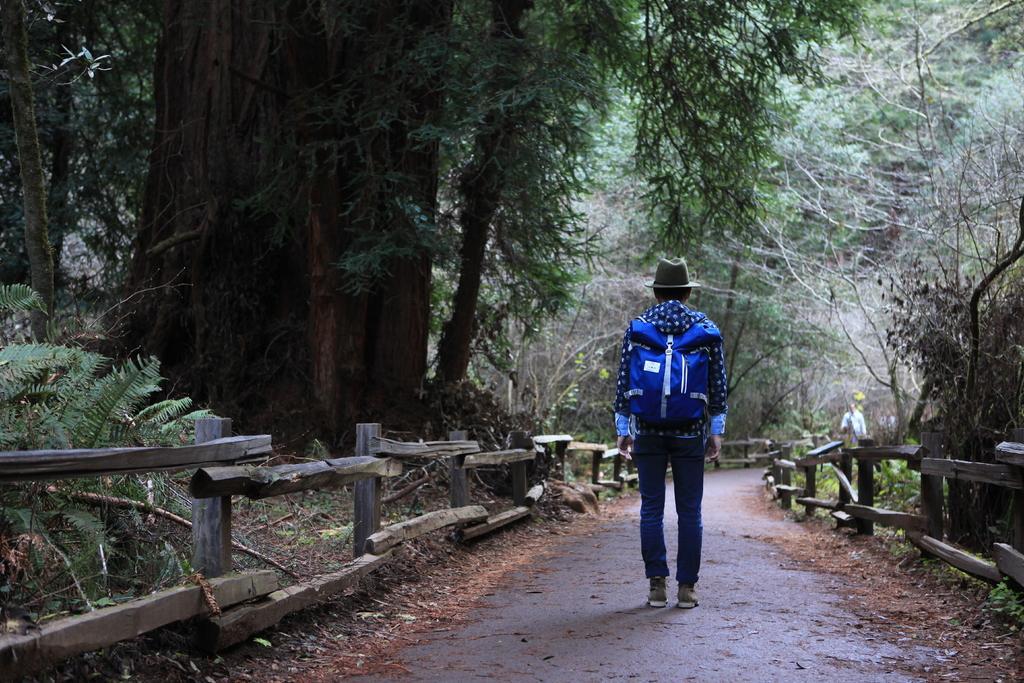Could you give a brief overview of what you see in this image? In this image I can see person standing and wearing a blue color bag and a hat. We can see trees and wooden fencing. 